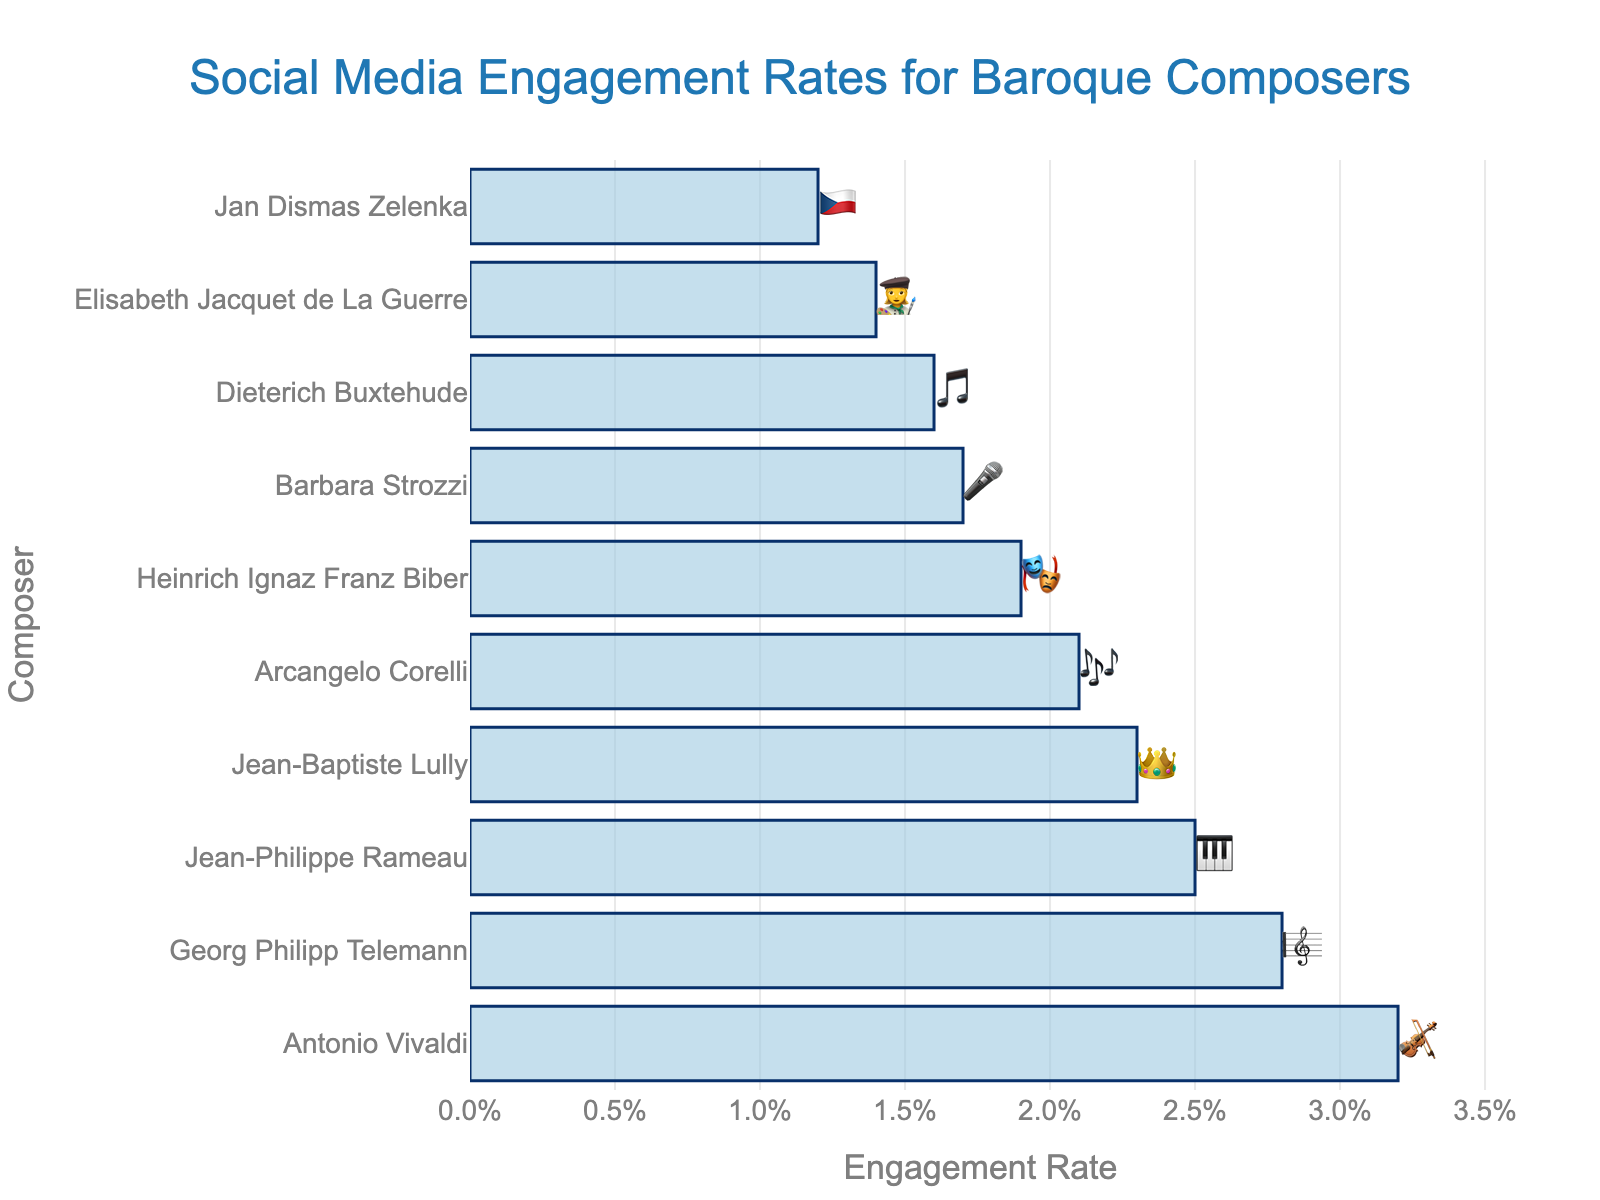what is the engagement rate for Antonio Vivaldi? By looking at the bar chart, we can directly see that Antonio Vivaldi's engagement rate is next to the emoji 🎻 and is marked as 3.2%.
Answer: 3.2% Which composer has the lowest engagement rate? The composer with the lowest engagement rate is the one with the smallest bar. The smallest bar belongs to Jan Dismas Zelenka, represented by the emoji 🇨🇿, with an engagement rate of 1.2%.
Answer: Jan Dismas Zelenka How much higher is Antonio Vivaldi’s engagement rate compared to Jean-Philippe Rameau's? First, we locate the engagement rates for Antonio Vivaldi (3.2%) and Jean-Philippe Rameau (2.5%) from the chart. Then, we find the difference: 3.2% - 2.5% = 0.7%.
Answer: 0.7% Which composer has the emoji 👑, and what is their engagement rate? The composer with the emoji 👑 is Jean-Baptiste Lully. His engagement rate is shown right next to it as 2.3%.
Answer: Jean-Baptiste Lully, 2.3% Order the composers from highest to lowest engagement rate. By examining the lengths of the bars from longest to shortest, the order is: Antonio Vivaldi, Georg Philipp Telemann, Jean-Philippe Rameau, Jean-Baptiste Lully, Arcangelo Corelli, Heinrich Ignaz Franz Biber, Barbara Strozzi, Dieterich Buxtehude, Elisabeth Jacquet de La Guerre, Jan Dismas Zelenka.
Answer: Antonio Vivaldi, Georg Philipp Telemann, Jean-Philippe Rameau, Jean-Baptiste Lully, Arcangelo Corelli, Heinrich Ignaz Franz Biber, Barbara Strozzi, Dieterich Buxtehude, Elisabeth Jacquet de La Guerre, Jan Dismas Zelenka What is the engagement rate difference between the highest and the lowest composers? The engagement rate for the highest composer (Antonio Vivaldi) is 3.2%, and the engagement rate for the lowest (Jan Dismas Zelenka) is 1.2%. The difference is calculated as follows: 3.2% - 1.2% = 2.0%.
Answer: 2.0% Which composer associated with the emoji 🎹, and what is their engagement rate? The composer associated with the emoji 🎹 is Jean-Philippe Rameau. His engagement rate is 2.5%.
Answer: Jean-Philippe Rameau, 2.5% Is Georg Philipp Telemann's engagement rate higher than Arcangelo Corelli’s, and by how much? Georg Philipp Telemann's engagement rate is 2.8%, whereas Arcangelo Corelli’s is 2.1%. The difference is 2.8% - 2.1% = 0.7%.
Answer: Yes, by 0.7% Which composer has a higher engagement rate, Heinrich Ignaz Franz Biber, or Barbara Strozzi? By comparing the bar lengths, Heinrich Ignaz Franz Biber (1.9%) has a higher engagement rate than Barbara Strozzi (1.7%).
Answer: Heinrich Ignaz Franz Biber 